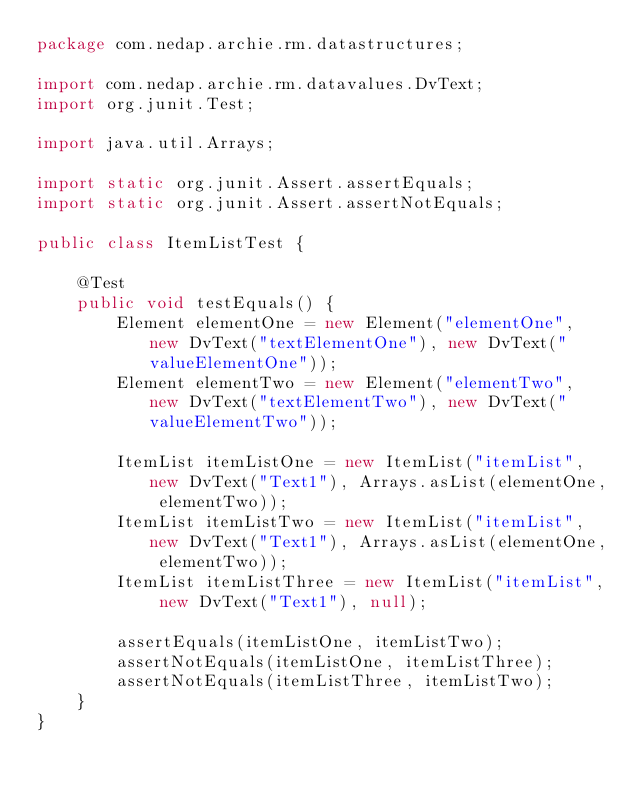<code> <loc_0><loc_0><loc_500><loc_500><_Java_>package com.nedap.archie.rm.datastructures;

import com.nedap.archie.rm.datavalues.DvText;
import org.junit.Test;

import java.util.Arrays;

import static org.junit.Assert.assertEquals;
import static org.junit.Assert.assertNotEquals;

public class ItemListTest {

    @Test
    public void testEquals() {
        Element elementOne = new Element("elementOne", new DvText("textElementOne"), new DvText("valueElementOne"));
        Element elementTwo = new Element("elementTwo", new DvText("textElementTwo"), new DvText("valueElementTwo"));

        ItemList itemListOne = new ItemList("itemList", new DvText("Text1"), Arrays.asList(elementOne, elementTwo));
        ItemList itemListTwo = new ItemList("itemList", new DvText("Text1"), Arrays.asList(elementOne, elementTwo));
        ItemList itemListThree = new ItemList("itemList", new DvText("Text1"), null);

        assertEquals(itemListOne, itemListTwo);
        assertNotEquals(itemListOne, itemListThree);
        assertNotEquals(itemListThree, itemListTwo);
    }
}</code> 